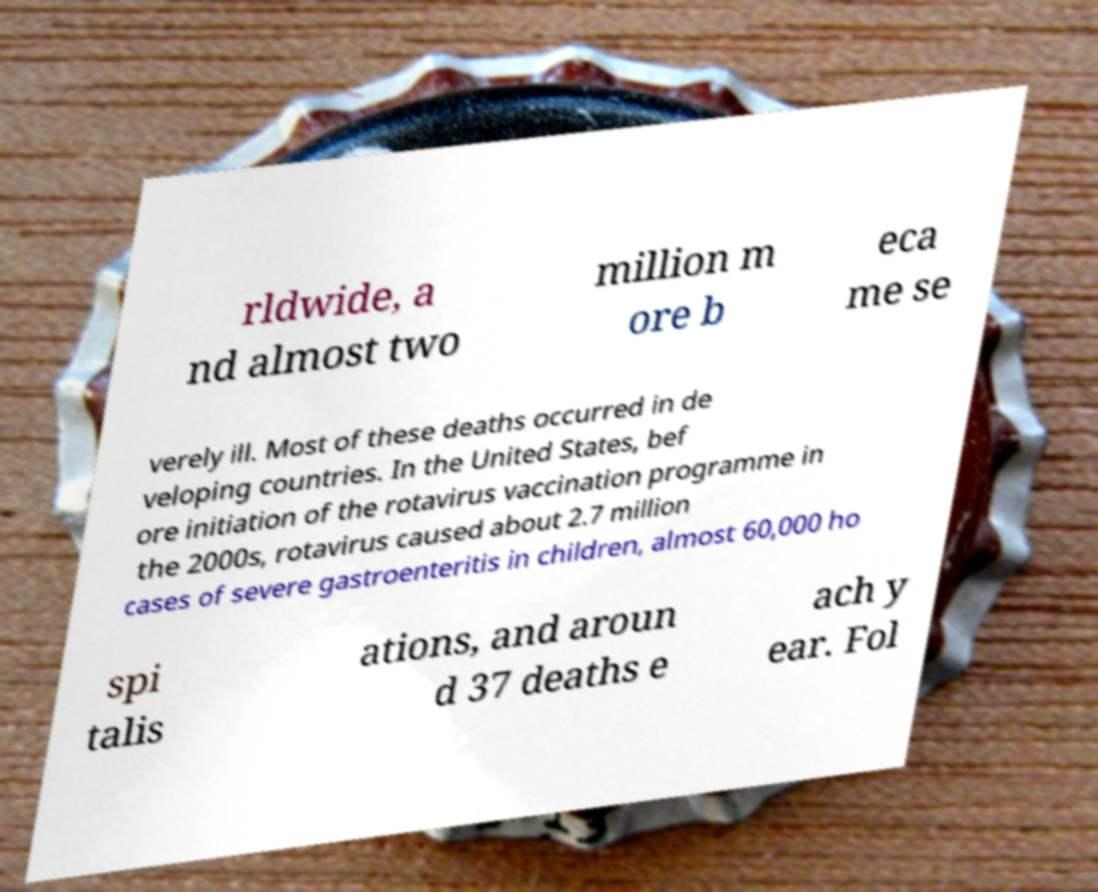Could you assist in decoding the text presented in this image and type it out clearly? rldwide, a nd almost two million m ore b eca me se verely ill. Most of these deaths occurred in de veloping countries. In the United States, bef ore initiation of the rotavirus vaccination programme in the 2000s, rotavirus caused about 2.7 million cases of severe gastroenteritis in children, almost 60,000 ho spi talis ations, and aroun d 37 deaths e ach y ear. Fol 